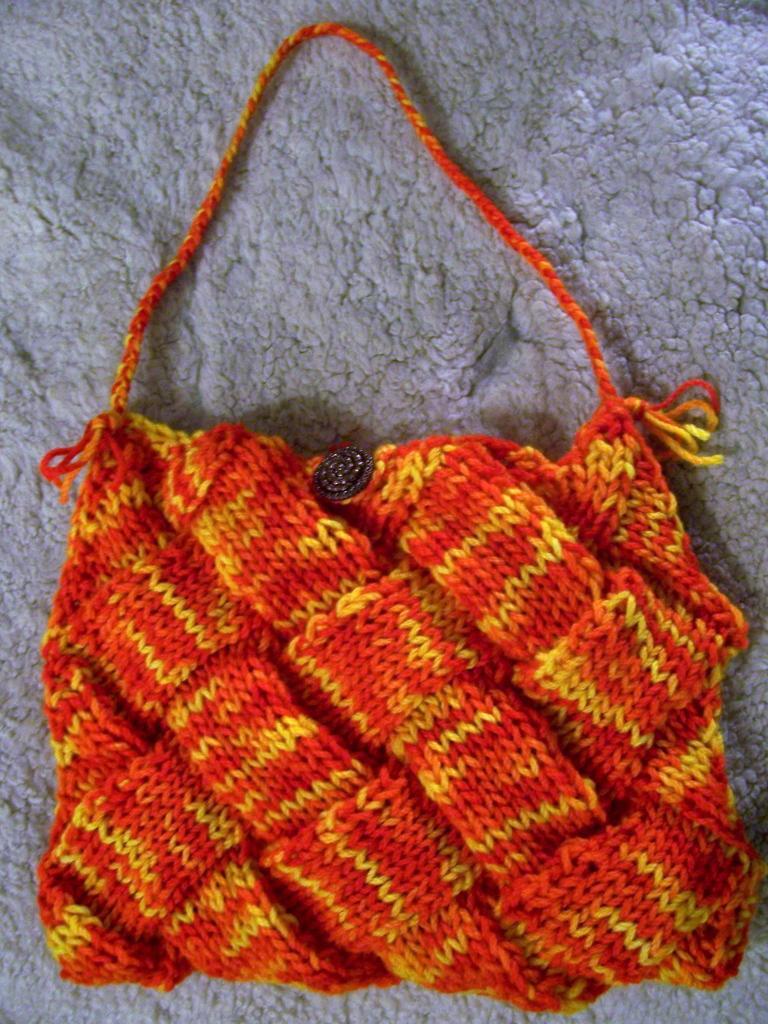Please provide a concise description of this image. This picture consists of a bag which is red in colour. 